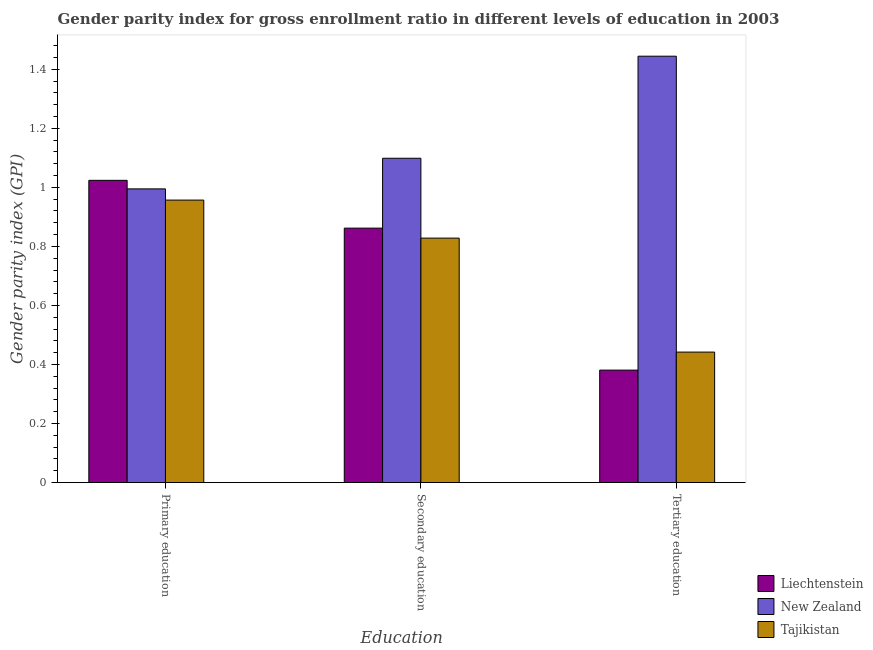Are the number of bars per tick equal to the number of legend labels?
Make the answer very short. Yes. How many bars are there on the 3rd tick from the right?
Your response must be concise. 3. What is the label of the 1st group of bars from the left?
Provide a succinct answer. Primary education. What is the gender parity index in primary education in Liechtenstein?
Give a very brief answer. 1.02. Across all countries, what is the maximum gender parity index in primary education?
Give a very brief answer. 1.02. Across all countries, what is the minimum gender parity index in primary education?
Your answer should be compact. 0.96. In which country was the gender parity index in secondary education maximum?
Provide a succinct answer. New Zealand. In which country was the gender parity index in secondary education minimum?
Your answer should be compact. Tajikistan. What is the total gender parity index in tertiary education in the graph?
Provide a succinct answer. 2.27. What is the difference between the gender parity index in tertiary education in New Zealand and that in Tajikistan?
Your answer should be very brief. 1. What is the difference between the gender parity index in secondary education in Liechtenstein and the gender parity index in tertiary education in New Zealand?
Your answer should be compact. -0.58. What is the average gender parity index in primary education per country?
Make the answer very short. 0.99. What is the difference between the gender parity index in secondary education and gender parity index in tertiary education in New Zealand?
Give a very brief answer. -0.35. In how many countries, is the gender parity index in primary education greater than 0.7600000000000001 ?
Offer a terse response. 3. What is the ratio of the gender parity index in secondary education in New Zealand to that in Liechtenstein?
Give a very brief answer. 1.27. Is the difference between the gender parity index in secondary education in Tajikistan and Liechtenstein greater than the difference between the gender parity index in primary education in Tajikistan and Liechtenstein?
Your response must be concise. Yes. What is the difference between the highest and the second highest gender parity index in primary education?
Your answer should be very brief. 0.03. What is the difference between the highest and the lowest gender parity index in tertiary education?
Provide a short and direct response. 1.06. What does the 3rd bar from the left in Secondary education represents?
Your response must be concise. Tajikistan. What does the 3rd bar from the right in Tertiary education represents?
Offer a terse response. Liechtenstein. How many countries are there in the graph?
Keep it short and to the point. 3. Are the values on the major ticks of Y-axis written in scientific E-notation?
Give a very brief answer. No. Does the graph contain grids?
Make the answer very short. No. How are the legend labels stacked?
Make the answer very short. Vertical. What is the title of the graph?
Provide a succinct answer. Gender parity index for gross enrollment ratio in different levels of education in 2003. Does "Cote d'Ivoire" appear as one of the legend labels in the graph?
Provide a short and direct response. No. What is the label or title of the X-axis?
Your response must be concise. Education. What is the label or title of the Y-axis?
Give a very brief answer. Gender parity index (GPI). What is the Gender parity index (GPI) in Liechtenstein in Primary education?
Provide a short and direct response. 1.02. What is the Gender parity index (GPI) of New Zealand in Primary education?
Offer a terse response. 0.99. What is the Gender parity index (GPI) of Tajikistan in Primary education?
Offer a terse response. 0.96. What is the Gender parity index (GPI) of Liechtenstein in Secondary education?
Give a very brief answer. 0.86. What is the Gender parity index (GPI) of New Zealand in Secondary education?
Offer a terse response. 1.1. What is the Gender parity index (GPI) of Tajikistan in Secondary education?
Ensure brevity in your answer.  0.83. What is the Gender parity index (GPI) of Liechtenstein in Tertiary education?
Offer a terse response. 0.38. What is the Gender parity index (GPI) in New Zealand in Tertiary education?
Offer a very short reply. 1.44. What is the Gender parity index (GPI) in Tajikistan in Tertiary education?
Provide a succinct answer. 0.44. Across all Education, what is the maximum Gender parity index (GPI) of Liechtenstein?
Your answer should be compact. 1.02. Across all Education, what is the maximum Gender parity index (GPI) in New Zealand?
Ensure brevity in your answer.  1.44. Across all Education, what is the maximum Gender parity index (GPI) in Tajikistan?
Provide a short and direct response. 0.96. Across all Education, what is the minimum Gender parity index (GPI) of Liechtenstein?
Offer a very short reply. 0.38. Across all Education, what is the minimum Gender parity index (GPI) in New Zealand?
Keep it short and to the point. 0.99. Across all Education, what is the minimum Gender parity index (GPI) of Tajikistan?
Provide a succinct answer. 0.44. What is the total Gender parity index (GPI) in Liechtenstein in the graph?
Offer a very short reply. 2.27. What is the total Gender parity index (GPI) in New Zealand in the graph?
Offer a very short reply. 3.54. What is the total Gender parity index (GPI) of Tajikistan in the graph?
Your answer should be compact. 2.23. What is the difference between the Gender parity index (GPI) in Liechtenstein in Primary education and that in Secondary education?
Provide a succinct answer. 0.16. What is the difference between the Gender parity index (GPI) of New Zealand in Primary education and that in Secondary education?
Provide a succinct answer. -0.1. What is the difference between the Gender parity index (GPI) in Tajikistan in Primary education and that in Secondary education?
Offer a terse response. 0.13. What is the difference between the Gender parity index (GPI) of Liechtenstein in Primary education and that in Tertiary education?
Keep it short and to the point. 0.64. What is the difference between the Gender parity index (GPI) of New Zealand in Primary education and that in Tertiary education?
Provide a succinct answer. -0.45. What is the difference between the Gender parity index (GPI) of Tajikistan in Primary education and that in Tertiary education?
Your answer should be very brief. 0.51. What is the difference between the Gender parity index (GPI) in Liechtenstein in Secondary education and that in Tertiary education?
Make the answer very short. 0.48. What is the difference between the Gender parity index (GPI) of New Zealand in Secondary education and that in Tertiary education?
Offer a terse response. -0.35. What is the difference between the Gender parity index (GPI) of Tajikistan in Secondary education and that in Tertiary education?
Provide a short and direct response. 0.39. What is the difference between the Gender parity index (GPI) in Liechtenstein in Primary education and the Gender parity index (GPI) in New Zealand in Secondary education?
Provide a short and direct response. -0.07. What is the difference between the Gender parity index (GPI) of Liechtenstein in Primary education and the Gender parity index (GPI) of Tajikistan in Secondary education?
Ensure brevity in your answer.  0.2. What is the difference between the Gender parity index (GPI) of Liechtenstein in Primary education and the Gender parity index (GPI) of New Zealand in Tertiary education?
Ensure brevity in your answer.  -0.42. What is the difference between the Gender parity index (GPI) of Liechtenstein in Primary education and the Gender parity index (GPI) of Tajikistan in Tertiary education?
Provide a short and direct response. 0.58. What is the difference between the Gender parity index (GPI) of New Zealand in Primary education and the Gender parity index (GPI) of Tajikistan in Tertiary education?
Provide a succinct answer. 0.55. What is the difference between the Gender parity index (GPI) of Liechtenstein in Secondary education and the Gender parity index (GPI) of New Zealand in Tertiary education?
Ensure brevity in your answer.  -0.58. What is the difference between the Gender parity index (GPI) in Liechtenstein in Secondary education and the Gender parity index (GPI) in Tajikistan in Tertiary education?
Make the answer very short. 0.42. What is the difference between the Gender parity index (GPI) in New Zealand in Secondary education and the Gender parity index (GPI) in Tajikistan in Tertiary education?
Provide a succinct answer. 0.66. What is the average Gender parity index (GPI) in Liechtenstein per Education?
Give a very brief answer. 0.76. What is the average Gender parity index (GPI) in New Zealand per Education?
Make the answer very short. 1.18. What is the average Gender parity index (GPI) of Tajikistan per Education?
Make the answer very short. 0.74. What is the difference between the Gender parity index (GPI) of Liechtenstein and Gender parity index (GPI) of New Zealand in Primary education?
Make the answer very short. 0.03. What is the difference between the Gender parity index (GPI) of Liechtenstein and Gender parity index (GPI) of Tajikistan in Primary education?
Your answer should be very brief. 0.07. What is the difference between the Gender parity index (GPI) of New Zealand and Gender parity index (GPI) of Tajikistan in Primary education?
Provide a short and direct response. 0.04. What is the difference between the Gender parity index (GPI) of Liechtenstein and Gender parity index (GPI) of New Zealand in Secondary education?
Offer a very short reply. -0.24. What is the difference between the Gender parity index (GPI) in Liechtenstein and Gender parity index (GPI) in Tajikistan in Secondary education?
Make the answer very short. 0.03. What is the difference between the Gender parity index (GPI) in New Zealand and Gender parity index (GPI) in Tajikistan in Secondary education?
Offer a terse response. 0.27. What is the difference between the Gender parity index (GPI) of Liechtenstein and Gender parity index (GPI) of New Zealand in Tertiary education?
Keep it short and to the point. -1.06. What is the difference between the Gender parity index (GPI) in Liechtenstein and Gender parity index (GPI) in Tajikistan in Tertiary education?
Your response must be concise. -0.06. What is the ratio of the Gender parity index (GPI) of Liechtenstein in Primary education to that in Secondary education?
Your answer should be very brief. 1.19. What is the ratio of the Gender parity index (GPI) in New Zealand in Primary education to that in Secondary education?
Your answer should be compact. 0.91. What is the ratio of the Gender parity index (GPI) of Tajikistan in Primary education to that in Secondary education?
Your answer should be compact. 1.16. What is the ratio of the Gender parity index (GPI) in Liechtenstein in Primary education to that in Tertiary education?
Make the answer very short. 2.69. What is the ratio of the Gender parity index (GPI) of New Zealand in Primary education to that in Tertiary education?
Keep it short and to the point. 0.69. What is the ratio of the Gender parity index (GPI) of Tajikistan in Primary education to that in Tertiary education?
Your answer should be very brief. 2.16. What is the ratio of the Gender parity index (GPI) in Liechtenstein in Secondary education to that in Tertiary education?
Keep it short and to the point. 2.26. What is the ratio of the Gender parity index (GPI) in New Zealand in Secondary education to that in Tertiary education?
Your response must be concise. 0.76. What is the ratio of the Gender parity index (GPI) of Tajikistan in Secondary education to that in Tertiary education?
Give a very brief answer. 1.87. What is the difference between the highest and the second highest Gender parity index (GPI) of Liechtenstein?
Your answer should be compact. 0.16. What is the difference between the highest and the second highest Gender parity index (GPI) of New Zealand?
Offer a terse response. 0.35. What is the difference between the highest and the second highest Gender parity index (GPI) in Tajikistan?
Your response must be concise. 0.13. What is the difference between the highest and the lowest Gender parity index (GPI) of Liechtenstein?
Offer a very short reply. 0.64. What is the difference between the highest and the lowest Gender parity index (GPI) of New Zealand?
Ensure brevity in your answer.  0.45. What is the difference between the highest and the lowest Gender parity index (GPI) of Tajikistan?
Provide a short and direct response. 0.51. 